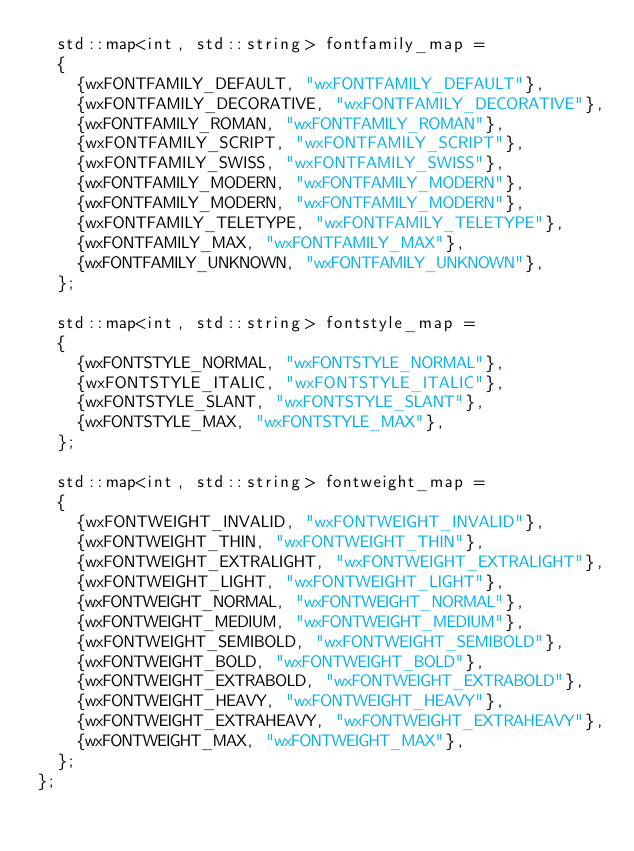Convert code to text. <code><loc_0><loc_0><loc_500><loc_500><_C_>	std::map<int, std::string> fontfamily_map =
	{
		{wxFONTFAMILY_DEFAULT, "wxFONTFAMILY_DEFAULT"},
		{wxFONTFAMILY_DECORATIVE, "wxFONTFAMILY_DECORATIVE"},
		{wxFONTFAMILY_ROMAN, "wxFONTFAMILY_ROMAN"},
		{wxFONTFAMILY_SCRIPT, "wxFONTFAMILY_SCRIPT"},
		{wxFONTFAMILY_SWISS, "wxFONTFAMILY_SWISS"},
		{wxFONTFAMILY_MODERN, "wxFONTFAMILY_MODERN"},
		{wxFONTFAMILY_MODERN, "wxFONTFAMILY_MODERN"},
		{wxFONTFAMILY_TELETYPE, "wxFONTFAMILY_TELETYPE"},
		{wxFONTFAMILY_MAX, "wxFONTFAMILY_MAX"},
		{wxFONTFAMILY_UNKNOWN, "wxFONTFAMILY_UNKNOWN"},
	};

	std::map<int, std::string> fontstyle_map =
	{
		{wxFONTSTYLE_NORMAL, "wxFONTSTYLE_NORMAL"},
		{wxFONTSTYLE_ITALIC, "wxFONTSTYLE_ITALIC"},
		{wxFONTSTYLE_SLANT, "wxFONTSTYLE_SLANT"},
		{wxFONTSTYLE_MAX, "wxFONTSTYLE_MAX"},
	};

	std::map<int, std::string> fontweight_map =
	{
		{wxFONTWEIGHT_INVALID, "wxFONTWEIGHT_INVALID"},
		{wxFONTWEIGHT_THIN, "wxFONTWEIGHT_THIN"},
		{wxFONTWEIGHT_EXTRALIGHT, "wxFONTWEIGHT_EXTRALIGHT"},
		{wxFONTWEIGHT_LIGHT, "wxFONTWEIGHT_LIGHT"},
		{wxFONTWEIGHT_NORMAL, "wxFONTWEIGHT_NORMAL"},
		{wxFONTWEIGHT_MEDIUM, "wxFONTWEIGHT_MEDIUM"},
		{wxFONTWEIGHT_SEMIBOLD, "wxFONTWEIGHT_SEMIBOLD"},
		{wxFONTWEIGHT_BOLD, "wxFONTWEIGHT_BOLD"},
		{wxFONTWEIGHT_EXTRABOLD, "wxFONTWEIGHT_EXTRABOLD"},
		{wxFONTWEIGHT_HEAVY, "wxFONTWEIGHT_HEAVY"},
		{wxFONTWEIGHT_EXTRAHEAVY, "wxFONTWEIGHT_EXTRAHEAVY"},
		{wxFONTWEIGHT_MAX, "wxFONTWEIGHT_MAX"},
	};
};</code> 